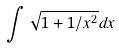Convert formula to latex. <formula><loc_0><loc_0><loc_500><loc_500>\int \sqrt { 1 + 1 / x ^ { 2 } } d x</formula> 